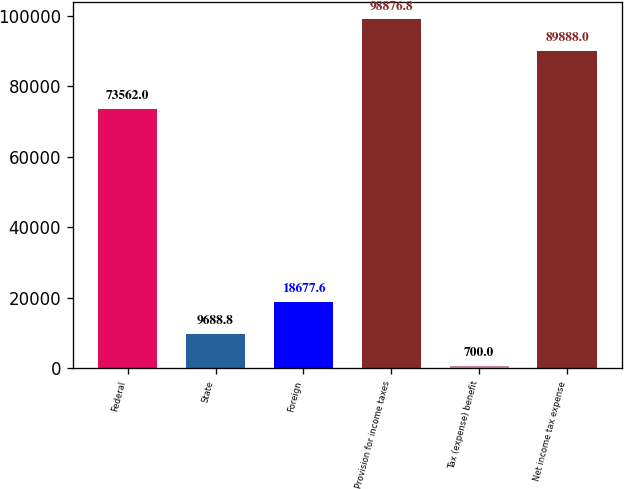Convert chart to OTSL. <chart><loc_0><loc_0><loc_500><loc_500><bar_chart><fcel>Federal<fcel>State<fcel>Foreign<fcel>Provision for income taxes<fcel>Tax (expense) benefit<fcel>Net income tax expense<nl><fcel>73562<fcel>9688.8<fcel>18677.6<fcel>98876.8<fcel>700<fcel>89888<nl></chart> 